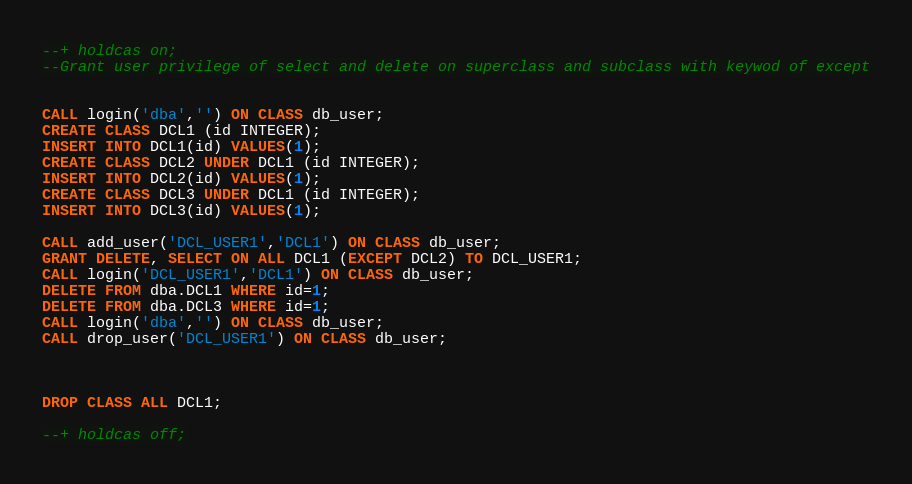<code> <loc_0><loc_0><loc_500><loc_500><_SQL_>--+ holdcas on;
--Grant user privilege of select and delete on superclass and subclass with keywod of except


CALL login('dba','') ON CLASS db_user;
CREATE CLASS DCL1 (id INTEGER);
INSERT INTO DCL1(id) VALUES(1);
CREATE CLASS DCL2 UNDER DCL1 (id INTEGER);
INSERT INTO DCL2(id) VALUES(1);
CREATE CLASS DCL3 UNDER DCL1 (id INTEGER);
INSERT INTO DCL3(id) VALUES(1);

CALL add_user('DCL_USER1','DCL1') ON CLASS db_user;
GRANT DELETE, SELECT ON ALL DCL1 (EXCEPT DCL2) TO DCL_USER1;
CALL login('DCL_USER1','DCL1') ON CLASS db_user;
DELETE FROM dba.DCL1 WHERE id=1;
DELETE FROM dba.DCL3 WHERE id=1;
CALL login('dba','') ON CLASS db_user;
CALL drop_user('DCL_USER1') ON CLASS db_user;



DROP CLASS ALL DCL1;

--+ holdcas off;
</code> 